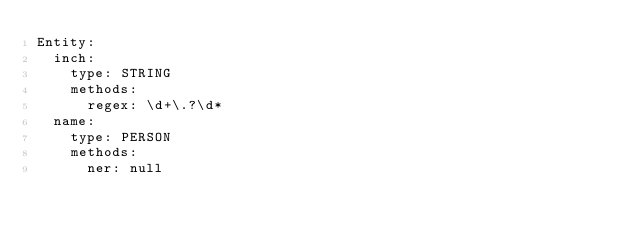<code> <loc_0><loc_0><loc_500><loc_500><_YAML_>Entity:
  inch:
    type: STRING
    methods:
      regex: \d+\.?\d*
  name:
    type: PERSON
    methods:
      ner: null
</code> 